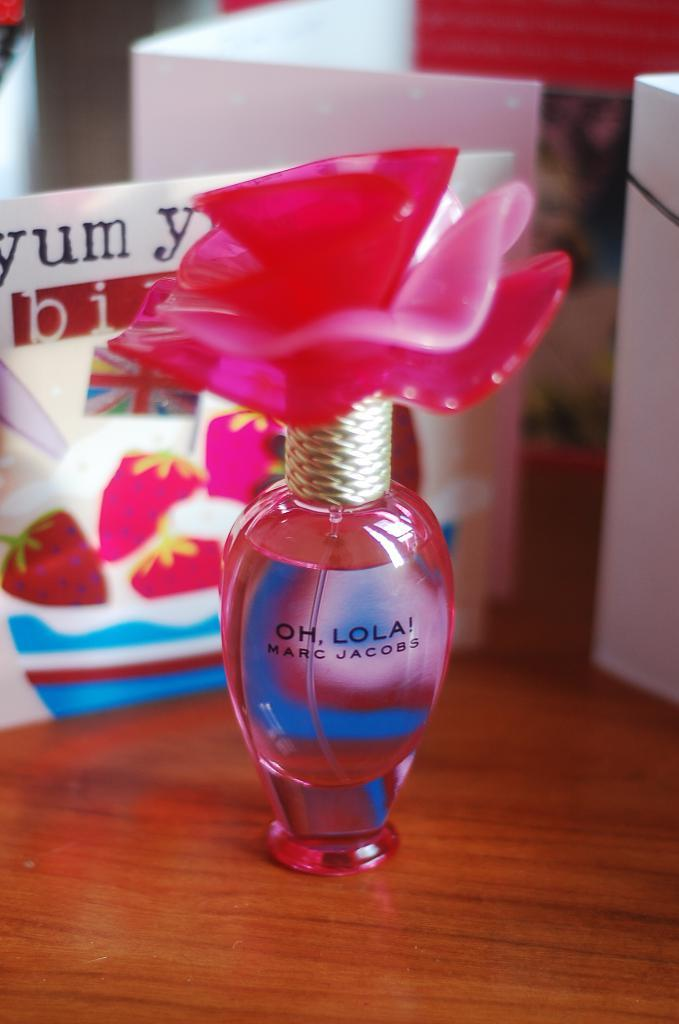What is the main subject in the center of the image? There is a perfume bottle in the center of the image. What is the background of the perfume bottle? There is a text board on a wooden surface behind the perfume bottle. What can be identified from the perfume bottle? The name of the perfume bottle is visible. How many pickles are placed on the pipe in the image? There are no pickles or pipes present in the image; it features a perfume bottle and a text board on a wooden surface. 